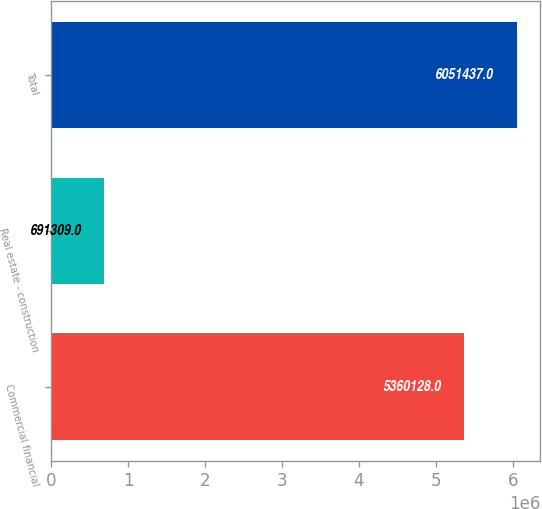<chart> <loc_0><loc_0><loc_500><loc_500><bar_chart><fcel>Commercial financial<fcel>Real estate - construction<fcel>Total<nl><fcel>5.36013e+06<fcel>691309<fcel>6.05144e+06<nl></chart> 